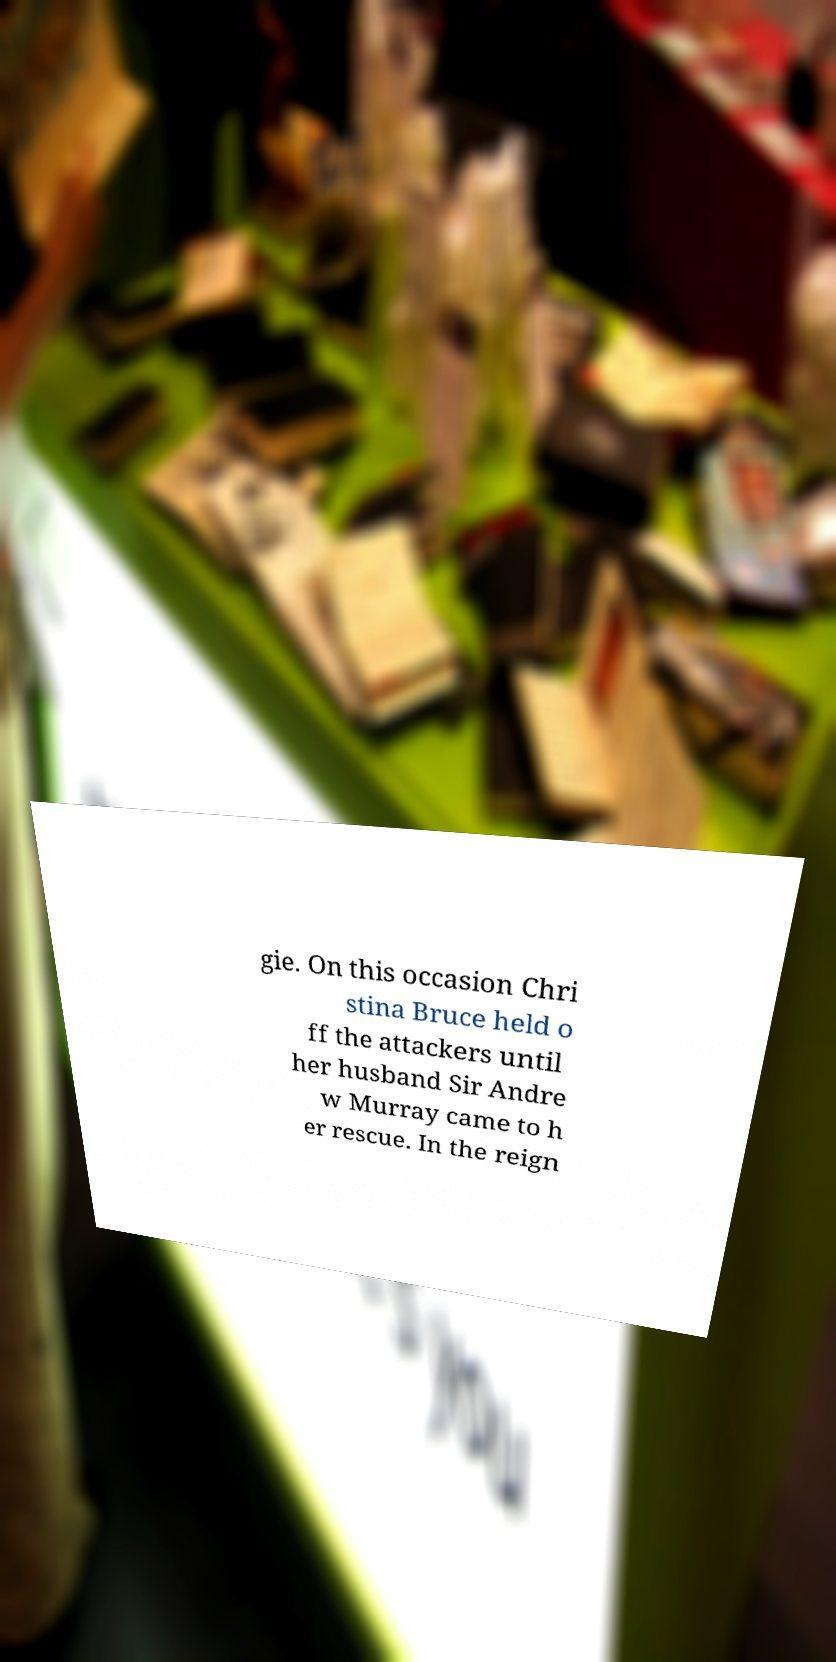What messages or text are displayed in this image? I need them in a readable, typed format. gie. On this occasion Chri stina Bruce held o ff the attackers until her husband Sir Andre w Murray came to h er rescue. In the reign 